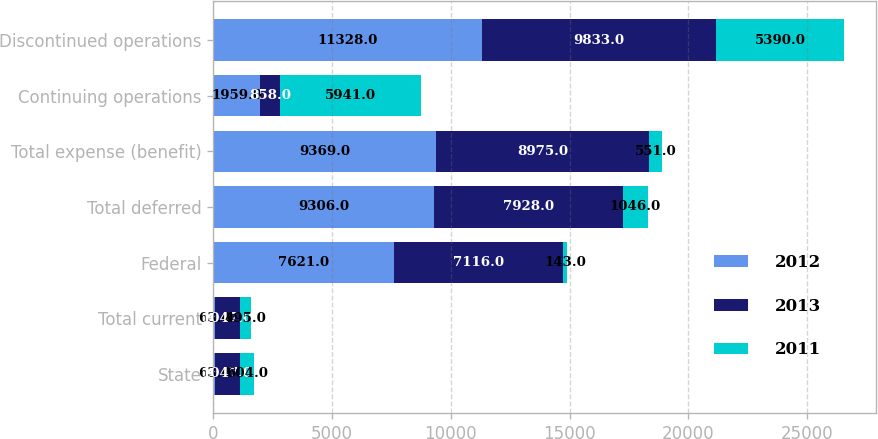Convert chart. <chart><loc_0><loc_0><loc_500><loc_500><stacked_bar_chart><ecel><fcel>State<fcel>Total current<fcel>Federal<fcel>Total deferred<fcel>Total expense (benefit)<fcel>Continuing operations<fcel>Discontinued operations<nl><fcel>2012<fcel>63<fcel>63<fcel>7621<fcel>9306<fcel>9369<fcel>1959<fcel>11328<nl><fcel>2013<fcel>1047<fcel>1047<fcel>7116<fcel>7928<fcel>8975<fcel>858<fcel>9833<nl><fcel>2011<fcel>604<fcel>495<fcel>143<fcel>1046<fcel>551<fcel>5941<fcel>5390<nl></chart> 